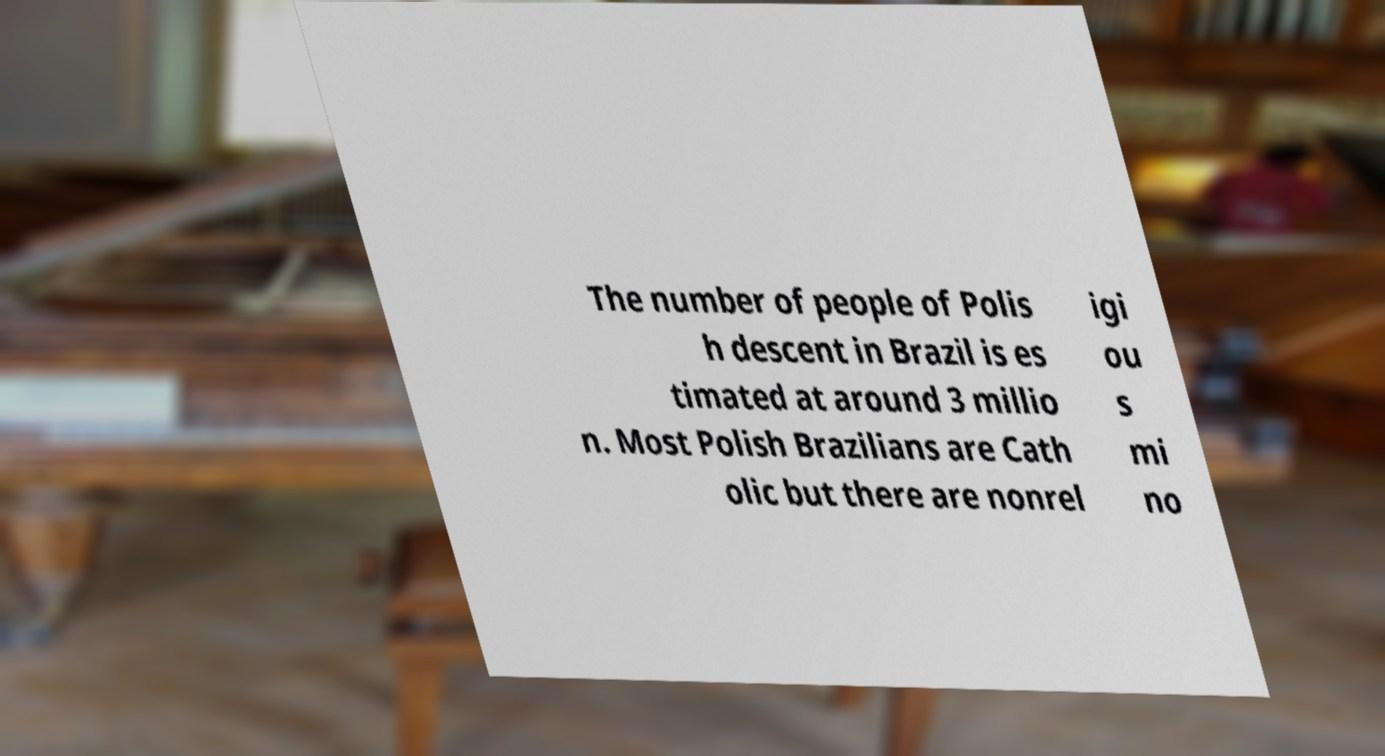What messages or text are displayed in this image? I need them in a readable, typed format. The number of people of Polis h descent in Brazil is es timated at around 3 millio n. Most Polish Brazilians are Cath olic but there are nonrel igi ou s mi no 